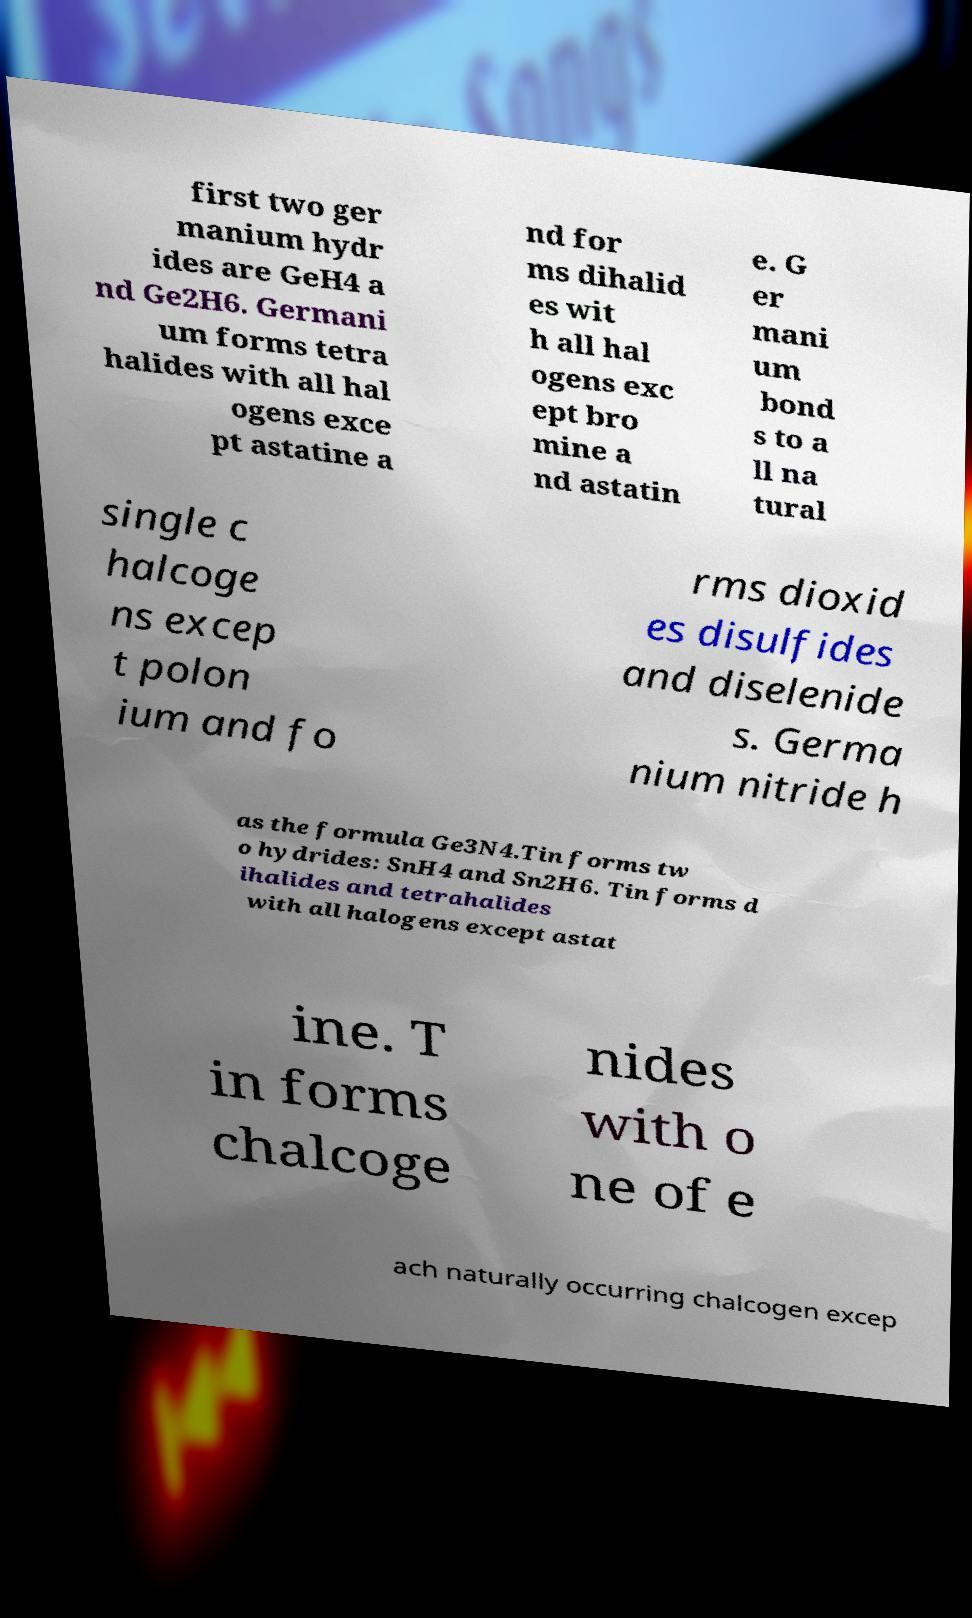Could you assist in decoding the text presented in this image and type it out clearly? first two ger manium hydr ides are GeH4 a nd Ge2H6. Germani um forms tetra halides with all hal ogens exce pt astatine a nd for ms dihalid es wit h all hal ogens exc ept bro mine a nd astatin e. G er mani um bond s to a ll na tural single c halcoge ns excep t polon ium and fo rms dioxid es disulfides and diselenide s. Germa nium nitride h as the formula Ge3N4.Tin forms tw o hydrides: SnH4 and Sn2H6. Tin forms d ihalides and tetrahalides with all halogens except astat ine. T in forms chalcoge nides with o ne of e ach naturally occurring chalcogen excep 